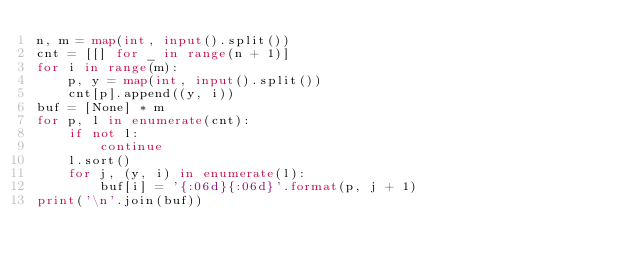Convert code to text. <code><loc_0><loc_0><loc_500><loc_500><_Python_>n, m = map(int, input().split())
cnt = [[] for _ in range(n + 1)]
for i in range(m):
    p, y = map(int, input().split())
    cnt[p].append((y, i))
buf = [None] * m
for p, l in enumerate(cnt):
    if not l:
        continue
    l.sort()
    for j, (y, i) in enumerate(l):
        buf[i] = '{:06d}{:06d}'.format(p, j + 1)
print('\n'.join(buf))</code> 